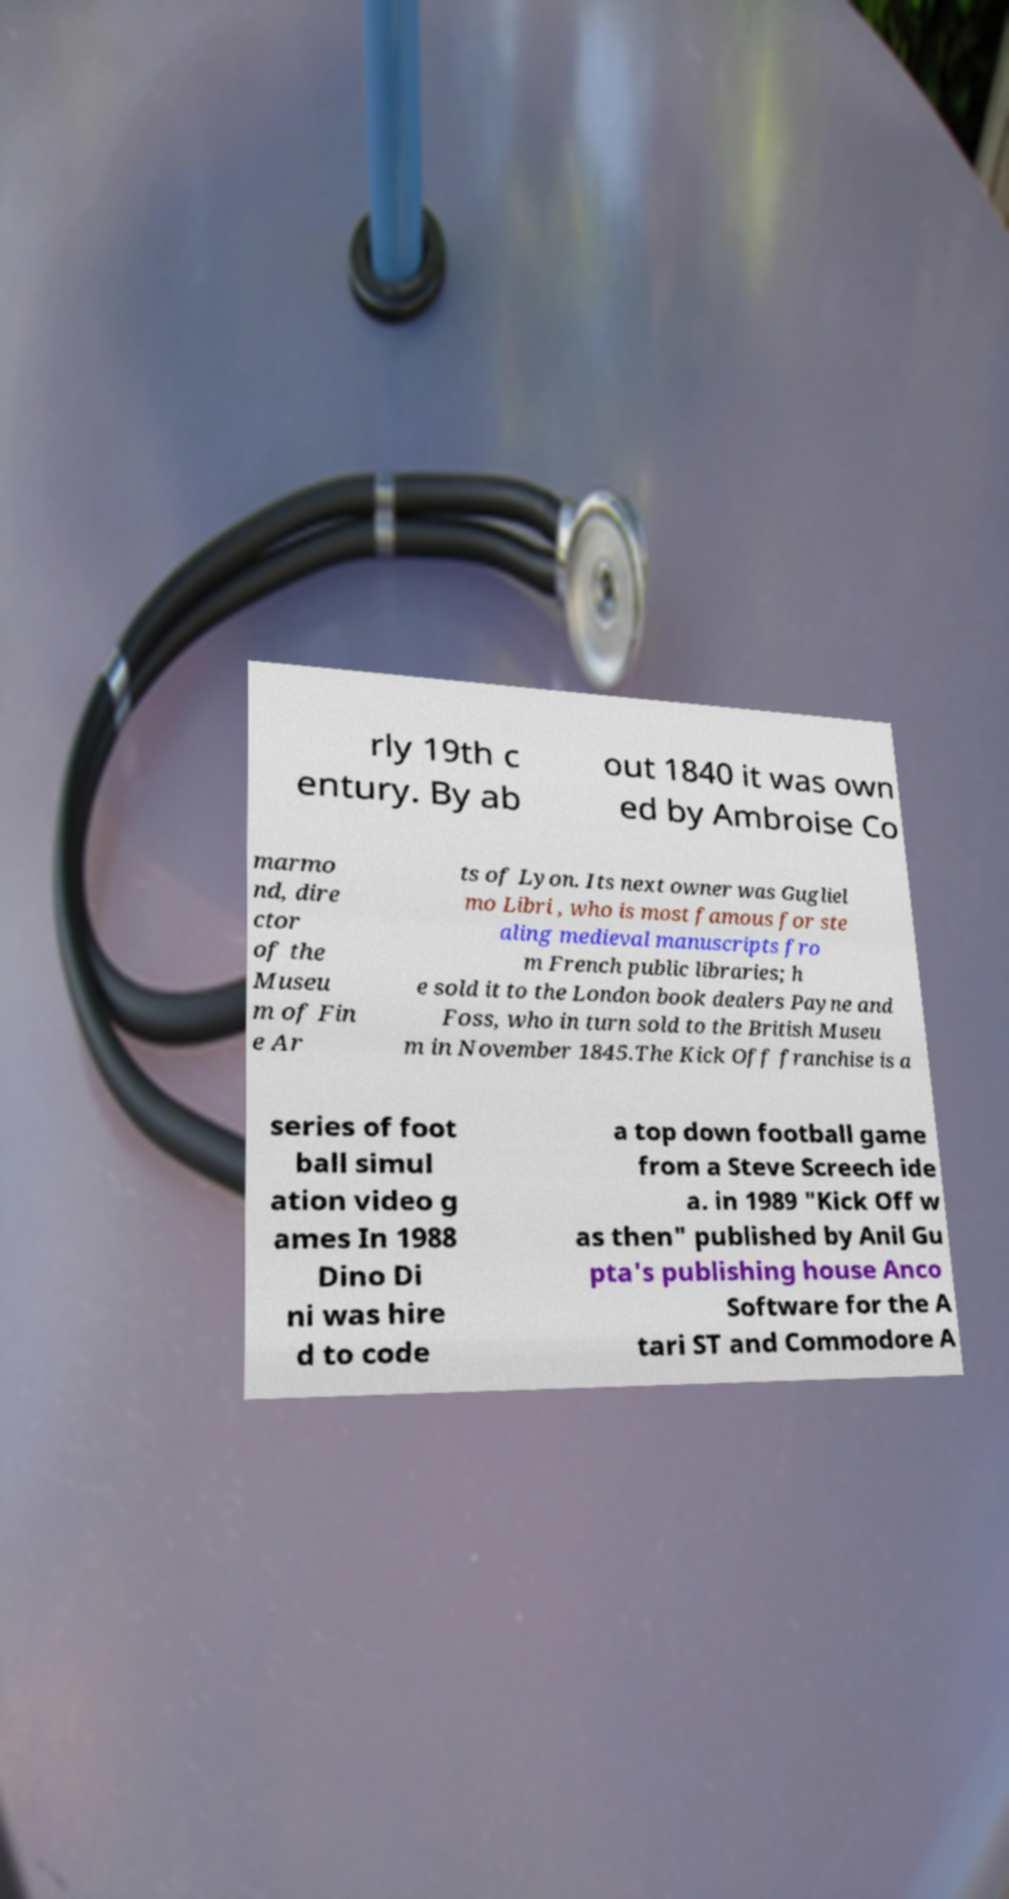Can you read and provide the text displayed in the image?This photo seems to have some interesting text. Can you extract and type it out for me? rly 19th c entury. By ab out 1840 it was own ed by Ambroise Co marmo nd, dire ctor of the Museu m of Fin e Ar ts of Lyon. Its next owner was Gugliel mo Libri , who is most famous for ste aling medieval manuscripts fro m French public libraries; h e sold it to the London book dealers Payne and Foss, who in turn sold to the British Museu m in November 1845.The Kick Off franchise is a series of foot ball simul ation video g ames In 1988 Dino Di ni was hire d to code a top down football game from a Steve Screech ide a. in 1989 "Kick Off w as then" published by Anil Gu pta's publishing house Anco Software for the A tari ST and Commodore A 